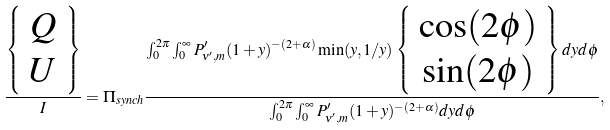Convert formula to latex. <formula><loc_0><loc_0><loc_500><loc_500>\frac { \left \{ \begin{array} { c } Q \\ U \\ \end{array} \right \} } { I } = \Pi _ { s y n c h } \frac { \int _ { 0 } ^ { 2 \pi } \int _ { 0 } ^ { \infty } P ^ { \prime } _ { \nu ^ { \prime } , m } ( 1 + y ) ^ { - ( 2 + \alpha ) } \min ( y , 1 / y ) \left \{ \begin{array} { c } \cos ( 2 \phi ) \\ \sin ( 2 \phi ) \\ \end{array} \right \} d y d \phi } { \int _ { 0 } ^ { 2 \pi } \int _ { 0 } ^ { \infty } P ^ { \prime } _ { \nu ^ { \prime } , m } ( 1 + y ) ^ { - ( 2 + \alpha ) } d y d \phi } ,</formula> 